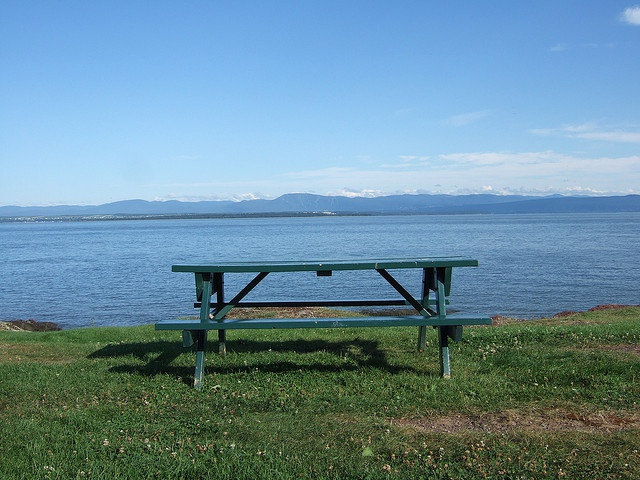Describe the objects in this image and their specific colors. I can see a bench in lightblue, black, gray, and teal tones in this image. 